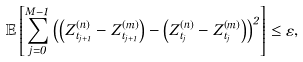Convert formula to latex. <formula><loc_0><loc_0><loc_500><loc_500>\mathbb { E } \left [ \sum _ { j = 0 } ^ { M - 1 } \left ( \left ( Z _ { t _ { j + 1 } } ^ { \left ( n \right ) } - Z _ { t _ { j + 1 } } ^ { \left ( m \right ) } \right ) - \left ( Z _ { t _ { j } } ^ { \left ( n \right ) } - Z _ { t _ { j } } ^ { \left ( m \right ) } \right ) \right ) ^ { 2 } \right ] \leq \varepsilon ,</formula> 